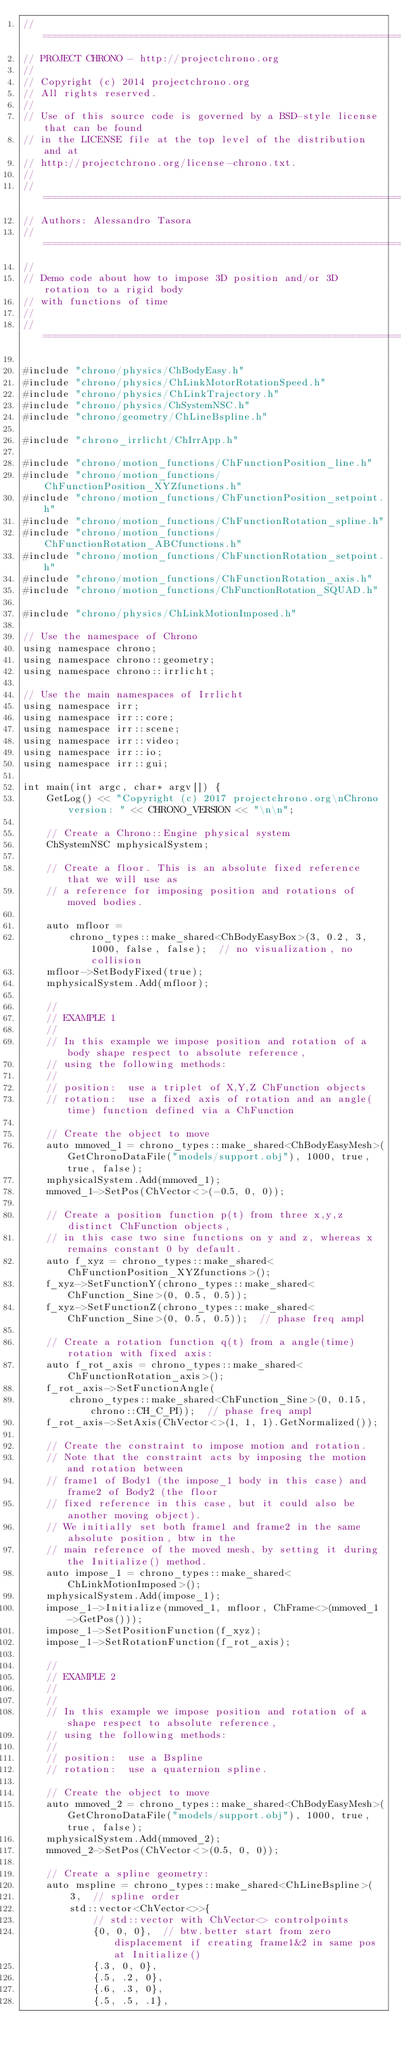Convert code to text. <code><loc_0><loc_0><loc_500><loc_500><_C++_>// =============================================================================
// PROJECT CHRONO - http://projectchrono.org
//
// Copyright (c) 2014 projectchrono.org
// All rights reserved.
//
// Use of this source code is governed by a BSD-style license that can be found
// in the LICENSE file at the top level of the distribution and at
// http://projectchrono.org/license-chrono.txt.
//
// =============================================================================
// Authors: Alessandro Tasora
// =============================================================================
//
// Demo code about how to impose 3D position and/or 3D rotation to a rigid body
// with functions of time
//
// =============================================================================

#include "chrono/physics/ChBodyEasy.h"
#include "chrono/physics/ChLinkMotorRotationSpeed.h"
#include "chrono/physics/ChLinkTrajectory.h"
#include "chrono/physics/ChSystemNSC.h"
#include "chrono/geometry/ChLineBspline.h"

#include "chrono_irrlicht/ChIrrApp.h"

#include "chrono/motion_functions/ChFunctionPosition_line.h"
#include "chrono/motion_functions/ChFunctionPosition_XYZfunctions.h"
#include "chrono/motion_functions/ChFunctionPosition_setpoint.h"
#include "chrono/motion_functions/ChFunctionRotation_spline.h"
#include "chrono/motion_functions/ChFunctionRotation_ABCfunctions.h"
#include "chrono/motion_functions/ChFunctionRotation_setpoint.h"
#include "chrono/motion_functions/ChFunctionRotation_axis.h"
#include "chrono/motion_functions/ChFunctionRotation_SQUAD.h"

#include "chrono/physics/ChLinkMotionImposed.h"

// Use the namespace of Chrono
using namespace chrono;
using namespace chrono::geometry;
using namespace chrono::irrlicht;

// Use the main namespaces of Irrlicht
using namespace irr;
using namespace irr::core;
using namespace irr::scene;
using namespace irr::video;
using namespace irr::io;
using namespace irr::gui;

int main(int argc, char* argv[]) {
    GetLog() << "Copyright (c) 2017 projectchrono.org\nChrono version: " << CHRONO_VERSION << "\n\n";

    // Create a Chrono::Engine physical system
    ChSystemNSC mphysicalSystem;

    // Create a floor. This is an absolute fixed reference that we will use as
    // a reference for imposing position and rotations of moved bodies.

    auto mfloor =
        chrono_types::make_shared<ChBodyEasyBox>(3, 0.2, 3, 1000, false, false);  // no visualization, no collision
    mfloor->SetBodyFixed(true);
    mphysicalSystem.Add(mfloor);

    //
    // EXAMPLE 1
    //
    // In this example we impose position and rotation of a body shape respect to absolute reference,
    // using the following methods:
    //
    // position:  use a triplet of X,Y,Z ChFunction objects
    // rotation:  use a fixed axis of rotation and an angle(time) function defined via a ChFunction

    // Create the object to move
    auto mmoved_1 = chrono_types::make_shared<ChBodyEasyMesh>(GetChronoDataFile("models/support.obj"), 1000, true, true, false);
    mphysicalSystem.Add(mmoved_1);
    mmoved_1->SetPos(ChVector<>(-0.5, 0, 0));

    // Create a position function p(t) from three x,y,z distinct ChFunction objects,
    // in this case two sine functions on y and z, whereas x remains constant 0 by default.
    auto f_xyz = chrono_types::make_shared<ChFunctionPosition_XYZfunctions>();
    f_xyz->SetFunctionY(chrono_types::make_shared<ChFunction_Sine>(0, 0.5, 0.5));
    f_xyz->SetFunctionZ(chrono_types::make_shared<ChFunction_Sine>(0, 0.5, 0.5));  // phase freq ampl

    // Create a rotation function q(t) from a angle(time) rotation with fixed axis:
    auto f_rot_axis = chrono_types::make_shared<ChFunctionRotation_axis>();
    f_rot_axis->SetFunctionAngle(
        chrono_types::make_shared<ChFunction_Sine>(0, 0.15, chrono::CH_C_PI));  // phase freq ampl
    f_rot_axis->SetAxis(ChVector<>(1, 1, 1).GetNormalized());

    // Create the constraint to impose motion and rotation.
    // Note that the constraint acts by imposing the motion and rotation between
    // frame1 of Body1 (the impose_1 body in this case) and frame2 of Body2 (the floor
    // fixed reference in this case, but it could also be another moving object).
    // We initially set both frame1 and frame2 in the same absolute position, btw in the
    // main reference of the moved mesh, by setting it during the Initialize() method.
    auto impose_1 = chrono_types::make_shared<ChLinkMotionImposed>();
    mphysicalSystem.Add(impose_1);
    impose_1->Initialize(mmoved_1, mfloor, ChFrame<>(mmoved_1->GetPos()));
    impose_1->SetPositionFunction(f_xyz);
    impose_1->SetRotationFunction(f_rot_axis);

    //
    // EXAMPLE 2
    //
    //
    // In this example we impose position and rotation of a shape respect to absolute reference,
    // using the following methods:
    //
    // position:  use a Bspline
    // rotation:  use a quaternion spline.

    // Create the object to move
    auto mmoved_2 = chrono_types::make_shared<ChBodyEasyMesh>(GetChronoDataFile("models/support.obj"), 1000, true, true, false);
    mphysicalSystem.Add(mmoved_2);
    mmoved_2->SetPos(ChVector<>(0.5, 0, 0));

    // Create a spline geometry:
    auto mspline = chrono_types::make_shared<ChLineBspline>(
        3,  // spline order
        std::vector<ChVector<>>{
            // std::vector with ChVector<> controlpoints
            {0, 0, 0},  // btw.better start from zero displacement if creating frame1&2 in same pos at Initialize()
            {.3, 0, 0},
            {.5, .2, 0},
            {.6, .3, 0},
            {.5, .5, .1},</code> 